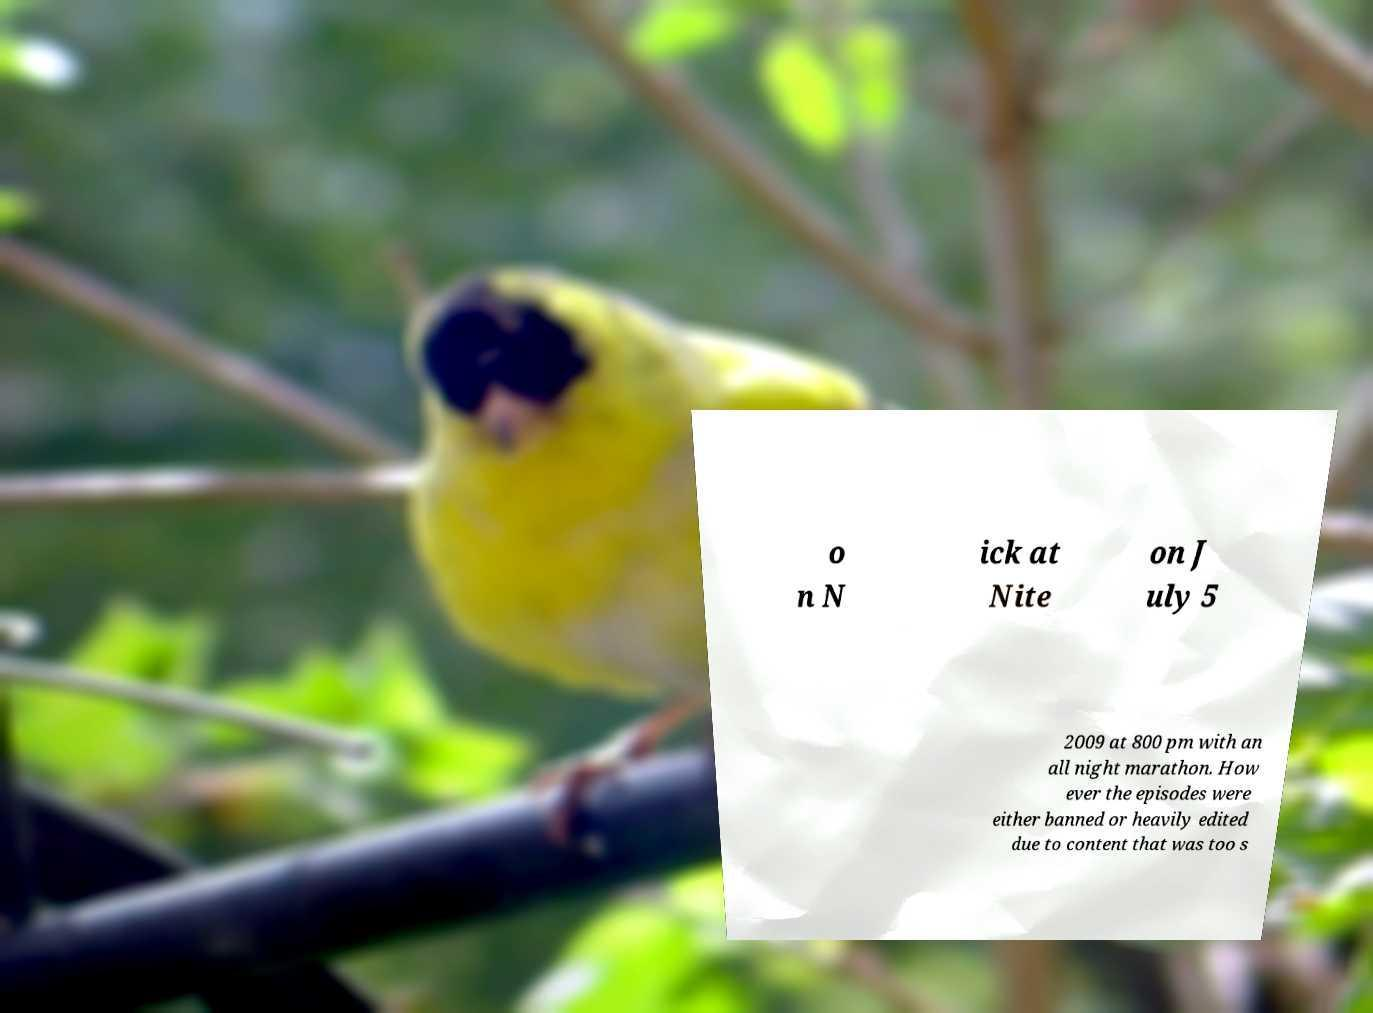I need the written content from this picture converted into text. Can you do that? o n N ick at Nite on J uly 5 2009 at 800 pm with an all night marathon. How ever the episodes were either banned or heavily edited due to content that was too s 